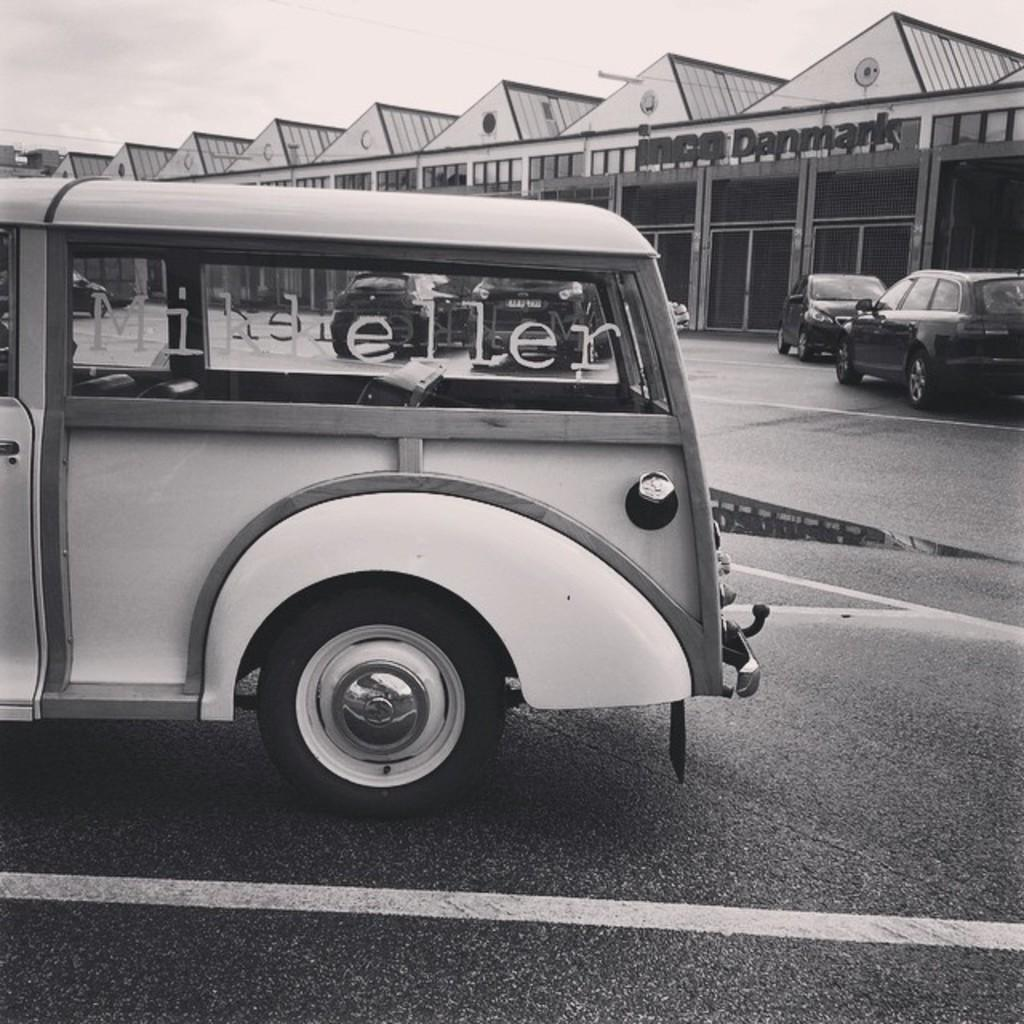What type of vehicle is on the road in the image? There is a van on the road in the image. What is the main feature at the bottom of the image? The image shows a road at the bottom. How many cars can be seen on the right side of the image? There are two cars on the right side of the image. What structure is visible in the background of the image? There is a shed visible in the background of the image. What is visible at the top of the image? The sky is visible at the top of the image. What type of leaf is being kicked by the van in the image? There is no leaf present in the image, and the van is not shown kicking anything. 